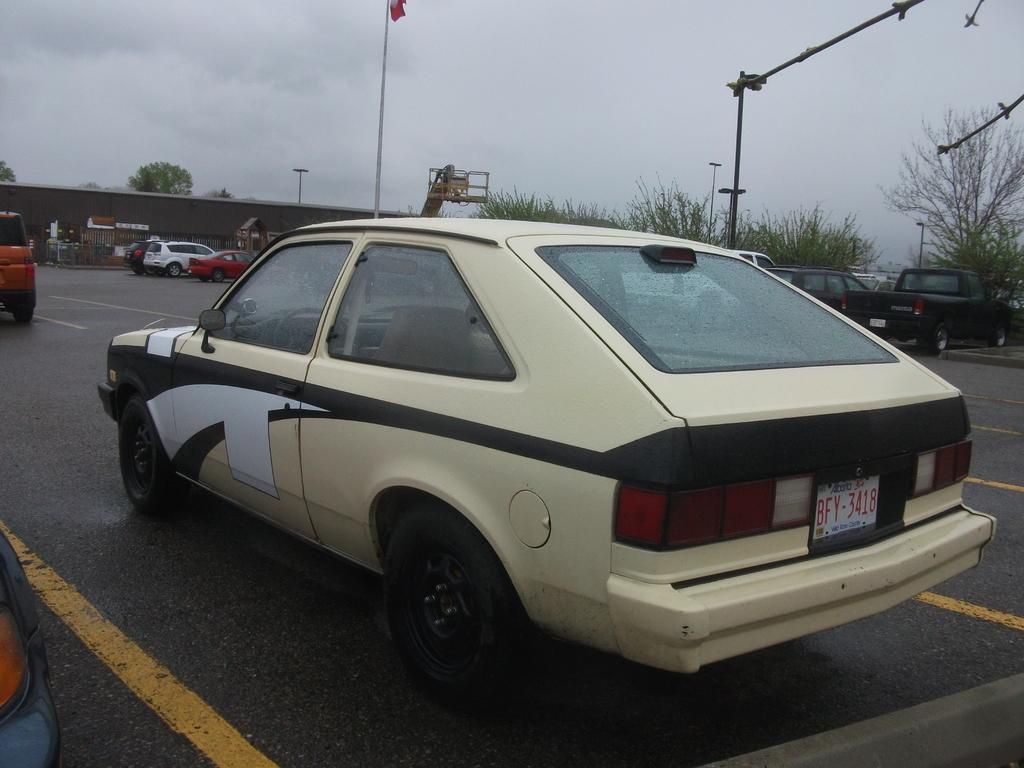What is happening on the road in the image? There are cars on the road in the image. What can be seen in the background behind the cars? There are trees and plants behind the cars. What is the large object behind the first car? There is a crane behind the first car. Where is the sandbox for the children to play in the image? There is no sandbox or children present in the image. What type of yard can be seen in the image? There is no yard visible in the image; it features a road with cars and a crane. 